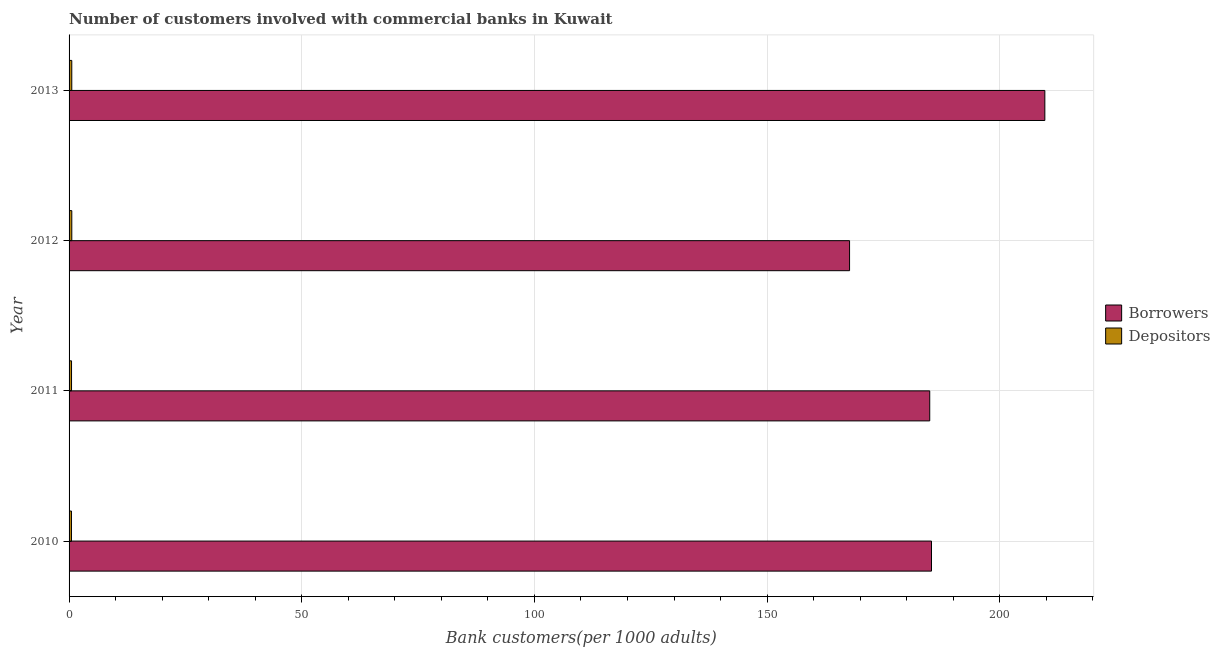How many different coloured bars are there?
Provide a succinct answer. 2. Are the number of bars per tick equal to the number of legend labels?
Offer a very short reply. Yes. Are the number of bars on each tick of the Y-axis equal?
Ensure brevity in your answer.  Yes. How many bars are there on the 3rd tick from the top?
Offer a very short reply. 2. How many bars are there on the 3rd tick from the bottom?
Provide a short and direct response. 2. In how many cases, is the number of bars for a given year not equal to the number of legend labels?
Offer a very short reply. 0. What is the number of depositors in 2012?
Keep it short and to the point. 0.59. Across all years, what is the maximum number of depositors?
Offer a very short reply. 0.59. Across all years, what is the minimum number of depositors?
Your response must be concise. 0.51. In which year was the number of borrowers maximum?
Offer a very short reply. 2013. What is the total number of borrowers in the graph?
Make the answer very short. 747.65. What is the difference between the number of borrowers in 2011 and that in 2012?
Provide a succinct answer. 17.23. What is the difference between the number of depositors in 2010 and the number of borrowers in 2013?
Ensure brevity in your answer.  -209.16. What is the average number of depositors per year?
Ensure brevity in your answer.  0.55. In the year 2012, what is the difference between the number of borrowers and number of depositors?
Ensure brevity in your answer.  167.13. What is the ratio of the number of depositors in 2010 to that in 2011?
Your response must be concise. 0.97. Is the number of borrowers in 2010 less than that in 2012?
Give a very brief answer. No. Is the difference between the number of depositors in 2010 and 2011 greater than the difference between the number of borrowers in 2010 and 2011?
Ensure brevity in your answer.  No. What is the difference between the highest and the second highest number of borrowers?
Keep it short and to the point. 24.36. What is the difference between the highest and the lowest number of borrowers?
Your answer should be very brief. 41.96. In how many years, is the number of depositors greater than the average number of depositors taken over all years?
Offer a very short reply. 2. Is the sum of the number of depositors in 2010 and 2012 greater than the maximum number of borrowers across all years?
Provide a short and direct response. No. What does the 1st bar from the top in 2011 represents?
Your answer should be compact. Depositors. What does the 2nd bar from the bottom in 2011 represents?
Give a very brief answer. Depositors. How many years are there in the graph?
Offer a terse response. 4. What is the difference between two consecutive major ticks on the X-axis?
Provide a succinct answer. 50. Are the values on the major ticks of X-axis written in scientific E-notation?
Your answer should be very brief. No. How many legend labels are there?
Give a very brief answer. 2. What is the title of the graph?
Your answer should be very brief. Number of customers involved with commercial banks in Kuwait. Does "Registered firms" appear as one of the legend labels in the graph?
Provide a succinct answer. No. What is the label or title of the X-axis?
Your answer should be very brief. Bank customers(per 1000 adults). What is the label or title of the Y-axis?
Ensure brevity in your answer.  Year. What is the Bank customers(per 1000 adults) in Borrowers in 2010?
Your answer should be very brief. 185.32. What is the Bank customers(per 1000 adults) of Depositors in 2010?
Provide a succinct answer. 0.51. What is the Bank customers(per 1000 adults) in Borrowers in 2011?
Keep it short and to the point. 184.94. What is the Bank customers(per 1000 adults) of Depositors in 2011?
Offer a terse response. 0.53. What is the Bank customers(per 1000 adults) of Borrowers in 2012?
Make the answer very short. 167.71. What is the Bank customers(per 1000 adults) in Depositors in 2012?
Keep it short and to the point. 0.59. What is the Bank customers(per 1000 adults) of Borrowers in 2013?
Make the answer very short. 209.68. What is the Bank customers(per 1000 adults) of Depositors in 2013?
Provide a short and direct response. 0.58. Across all years, what is the maximum Bank customers(per 1000 adults) of Borrowers?
Give a very brief answer. 209.68. Across all years, what is the maximum Bank customers(per 1000 adults) of Depositors?
Offer a terse response. 0.59. Across all years, what is the minimum Bank customers(per 1000 adults) in Borrowers?
Provide a succinct answer. 167.71. Across all years, what is the minimum Bank customers(per 1000 adults) of Depositors?
Keep it short and to the point. 0.51. What is the total Bank customers(per 1000 adults) in Borrowers in the graph?
Make the answer very short. 747.65. What is the total Bank customers(per 1000 adults) in Depositors in the graph?
Provide a succinct answer. 2.21. What is the difference between the Bank customers(per 1000 adults) in Borrowers in 2010 and that in 2011?
Offer a very short reply. 0.38. What is the difference between the Bank customers(per 1000 adults) in Depositors in 2010 and that in 2011?
Provide a succinct answer. -0.01. What is the difference between the Bank customers(per 1000 adults) in Borrowers in 2010 and that in 2012?
Your answer should be very brief. 17.61. What is the difference between the Bank customers(per 1000 adults) in Depositors in 2010 and that in 2012?
Provide a short and direct response. -0.07. What is the difference between the Bank customers(per 1000 adults) in Borrowers in 2010 and that in 2013?
Your response must be concise. -24.35. What is the difference between the Bank customers(per 1000 adults) in Depositors in 2010 and that in 2013?
Make the answer very short. -0.07. What is the difference between the Bank customers(per 1000 adults) in Borrowers in 2011 and that in 2012?
Your answer should be compact. 17.23. What is the difference between the Bank customers(per 1000 adults) in Depositors in 2011 and that in 2012?
Provide a short and direct response. -0.06. What is the difference between the Bank customers(per 1000 adults) of Borrowers in 2011 and that in 2013?
Your answer should be compact. -24.73. What is the difference between the Bank customers(per 1000 adults) of Depositors in 2011 and that in 2013?
Provide a short and direct response. -0.05. What is the difference between the Bank customers(per 1000 adults) in Borrowers in 2012 and that in 2013?
Keep it short and to the point. -41.96. What is the difference between the Bank customers(per 1000 adults) in Depositors in 2012 and that in 2013?
Make the answer very short. 0. What is the difference between the Bank customers(per 1000 adults) in Borrowers in 2010 and the Bank customers(per 1000 adults) in Depositors in 2011?
Give a very brief answer. 184.79. What is the difference between the Bank customers(per 1000 adults) in Borrowers in 2010 and the Bank customers(per 1000 adults) in Depositors in 2012?
Make the answer very short. 184.74. What is the difference between the Bank customers(per 1000 adults) of Borrowers in 2010 and the Bank customers(per 1000 adults) of Depositors in 2013?
Give a very brief answer. 184.74. What is the difference between the Bank customers(per 1000 adults) in Borrowers in 2011 and the Bank customers(per 1000 adults) in Depositors in 2012?
Your response must be concise. 184.36. What is the difference between the Bank customers(per 1000 adults) of Borrowers in 2011 and the Bank customers(per 1000 adults) of Depositors in 2013?
Provide a short and direct response. 184.36. What is the difference between the Bank customers(per 1000 adults) of Borrowers in 2012 and the Bank customers(per 1000 adults) of Depositors in 2013?
Offer a terse response. 167.13. What is the average Bank customers(per 1000 adults) in Borrowers per year?
Offer a terse response. 186.91. What is the average Bank customers(per 1000 adults) in Depositors per year?
Provide a succinct answer. 0.55. In the year 2010, what is the difference between the Bank customers(per 1000 adults) in Borrowers and Bank customers(per 1000 adults) in Depositors?
Make the answer very short. 184.81. In the year 2011, what is the difference between the Bank customers(per 1000 adults) in Borrowers and Bank customers(per 1000 adults) in Depositors?
Ensure brevity in your answer.  184.41. In the year 2012, what is the difference between the Bank customers(per 1000 adults) of Borrowers and Bank customers(per 1000 adults) of Depositors?
Ensure brevity in your answer.  167.13. In the year 2013, what is the difference between the Bank customers(per 1000 adults) in Borrowers and Bank customers(per 1000 adults) in Depositors?
Give a very brief answer. 209.09. What is the ratio of the Bank customers(per 1000 adults) of Borrowers in 2010 to that in 2011?
Ensure brevity in your answer.  1. What is the ratio of the Bank customers(per 1000 adults) in Depositors in 2010 to that in 2011?
Your answer should be compact. 0.97. What is the ratio of the Bank customers(per 1000 adults) in Borrowers in 2010 to that in 2012?
Provide a short and direct response. 1.1. What is the ratio of the Bank customers(per 1000 adults) of Depositors in 2010 to that in 2012?
Make the answer very short. 0.88. What is the ratio of the Bank customers(per 1000 adults) in Borrowers in 2010 to that in 2013?
Ensure brevity in your answer.  0.88. What is the ratio of the Bank customers(per 1000 adults) of Depositors in 2010 to that in 2013?
Keep it short and to the point. 0.88. What is the ratio of the Bank customers(per 1000 adults) in Borrowers in 2011 to that in 2012?
Offer a very short reply. 1.1. What is the ratio of the Bank customers(per 1000 adults) of Depositors in 2011 to that in 2012?
Offer a very short reply. 0.9. What is the ratio of the Bank customers(per 1000 adults) of Borrowers in 2011 to that in 2013?
Provide a short and direct response. 0.88. What is the ratio of the Bank customers(per 1000 adults) of Depositors in 2011 to that in 2013?
Provide a short and direct response. 0.91. What is the ratio of the Bank customers(per 1000 adults) in Borrowers in 2012 to that in 2013?
Give a very brief answer. 0.8. What is the difference between the highest and the second highest Bank customers(per 1000 adults) of Borrowers?
Make the answer very short. 24.35. What is the difference between the highest and the second highest Bank customers(per 1000 adults) of Depositors?
Provide a short and direct response. 0. What is the difference between the highest and the lowest Bank customers(per 1000 adults) of Borrowers?
Your answer should be compact. 41.96. What is the difference between the highest and the lowest Bank customers(per 1000 adults) of Depositors?
Your answer should be very brief. 0.07. 